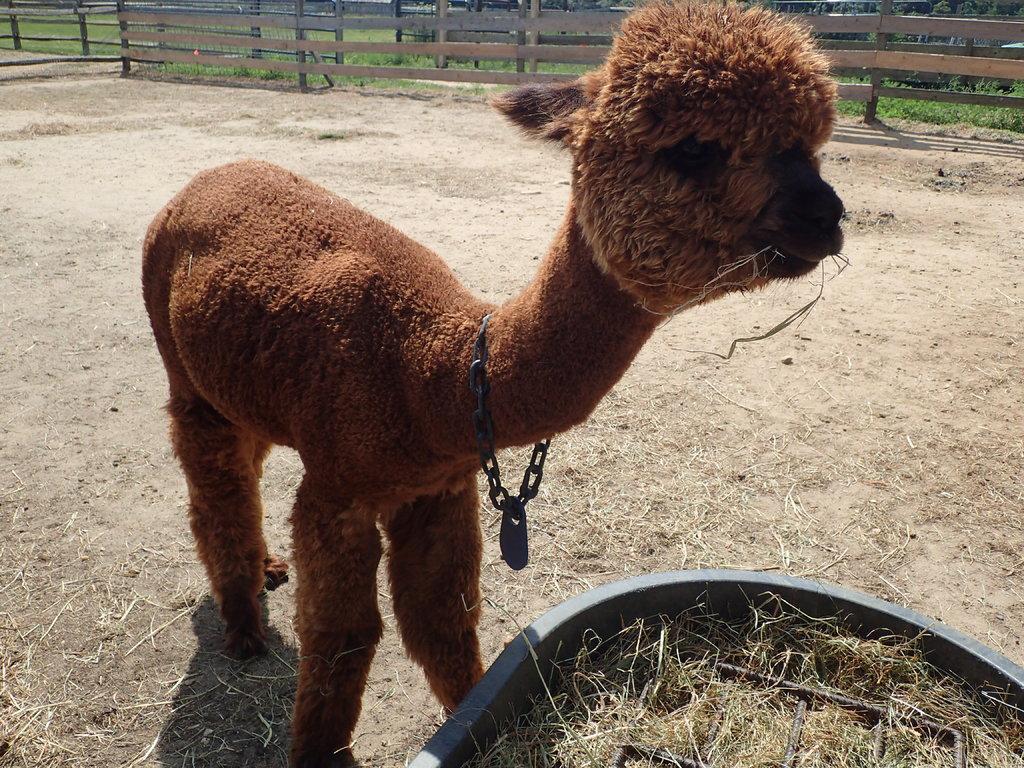Describe this image in one or two sentences. In this picture there is an animal on the ground and we can see grass and metal object in a container. In the background of the image we can see fence and grass. 